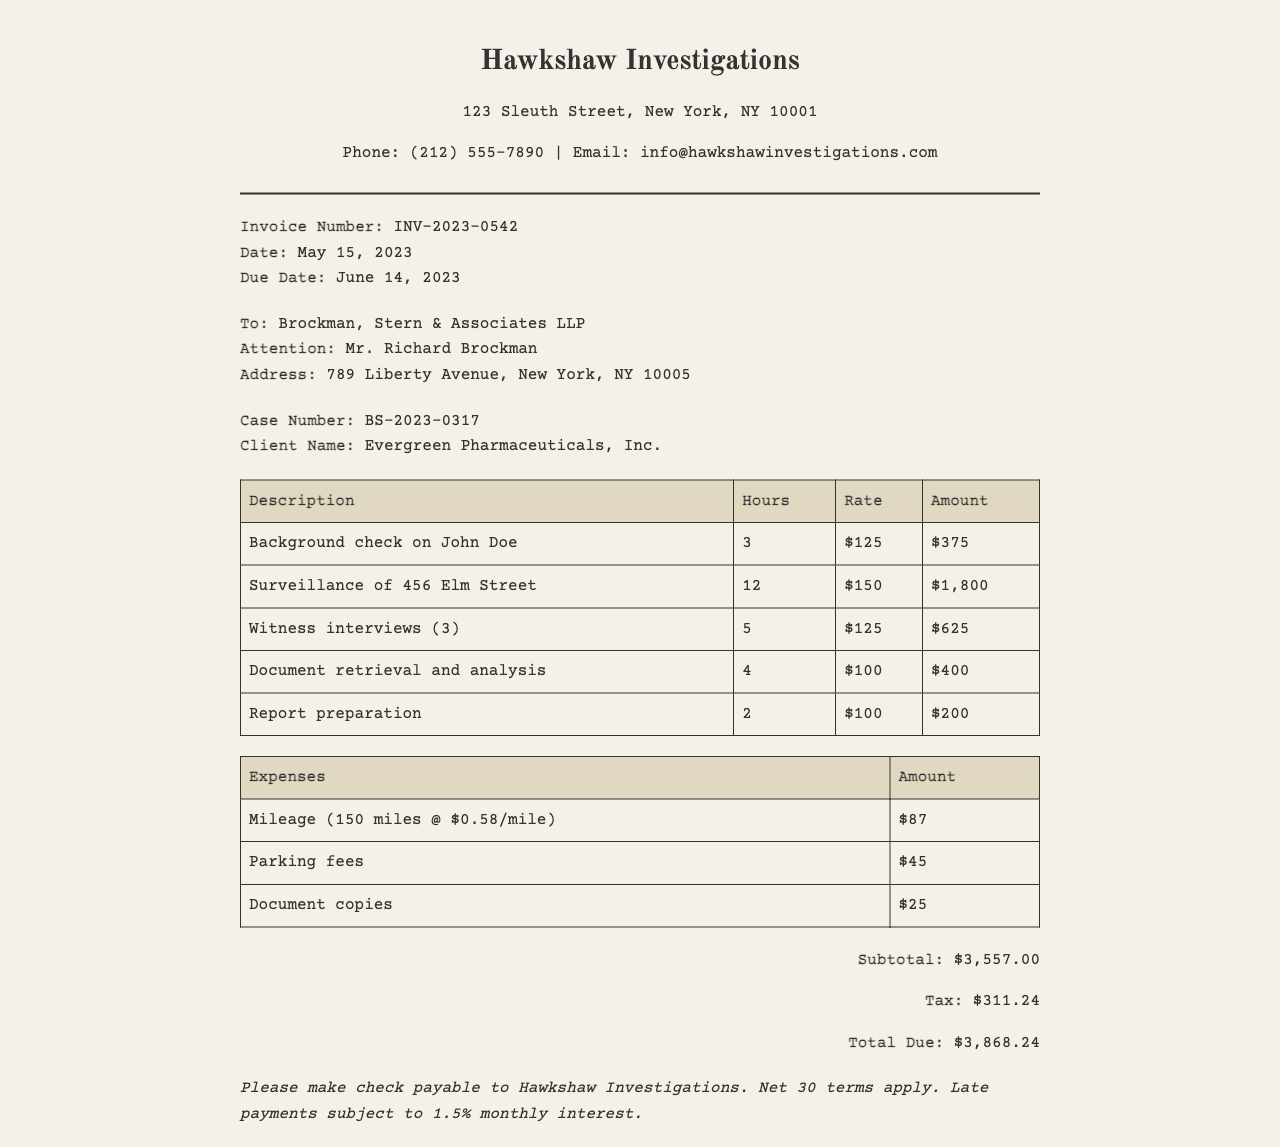What is the invoice number? The invoice number is specified on the document, which is INV-2023-0542.
Answer: INV-2023-0542 What is the due date? The due date is clearly stated in the document as June 14, 2023.
Answer: June 14, 2023 Who is the client? The client name is mentioned in the document, which is Evergreen Pharmaceuticals, Inc.
Answer: Evergreen Pharmaceuticals, Inc What is the subtotal amount? The subtotal amount is provided in the totals section of the document, which is $3,557.00.
Answer: $3,557.00 How many hours were billed for surveillance? The document lists the hours billed for surveillance, which is 12 hours.
Answer: 12 What is the tax amount? The tax amount is specified in the totals section, which is $311.24.
Answer: $311.24 What is the main service description for the highest billed amount? The service with the highest billed amount is surveillance of 456 Elm Street for $1,800.
Answer: Surveillance of 456 Elm Street What is the payment term? The payment term is described in the payment instructions, which state that net 30 terms apply.
Answer: Net 30 How much was charged for document copies? The charge for document copies is noted in the expenses section, which is $25.
Answer: $25 What is the rate per hour for witness interviews? The rate for witness interviews is stated in the document, which is $125 per hour.
Answer: $125 